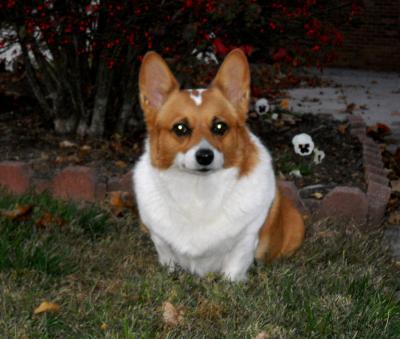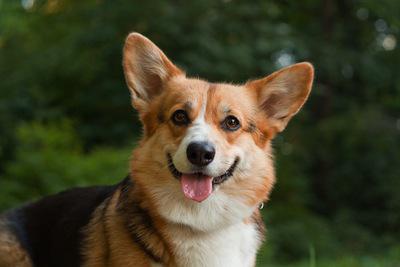The first image is the image on the left, the second image is the image on the right. Analyze the images presented: Is the assertion "The dogs are all either standing or sitting while looking at the camera." valid? Answer yes or no. Yes. The first image is the image on the left, the second image is the image on the right. Evaluate the accuracy of this statement regarding the images: "One dog has his mouth shut.". Is it true? Answer yes or no. Yes. 